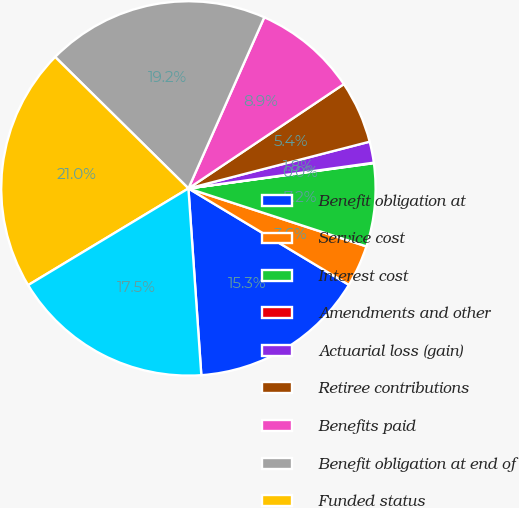Convert chart. <chart><loc_0><loc_0><loc_500><loc_500><pie_chart><fcel>Benefit obligation at<fcel>Service cost<fcel>Interest cost<fcel>Amendments and other<fcel>Actuarial loss (gain)<fcel>Retiree contributions<fcel>Benefits paid<fcel>Benefit obligation at end of<fcel>Funded status<fcel>Accrued benefit cost<nl><fcel>15.29%<fcel>3.6%<fcel>7.17%<fcel>0.04%<fcel>1.82%<fcel>5.39%<fcel>8.95%<fcel>19.25%<fcel>21.03%<fcel>17.46%<nl></chart> 